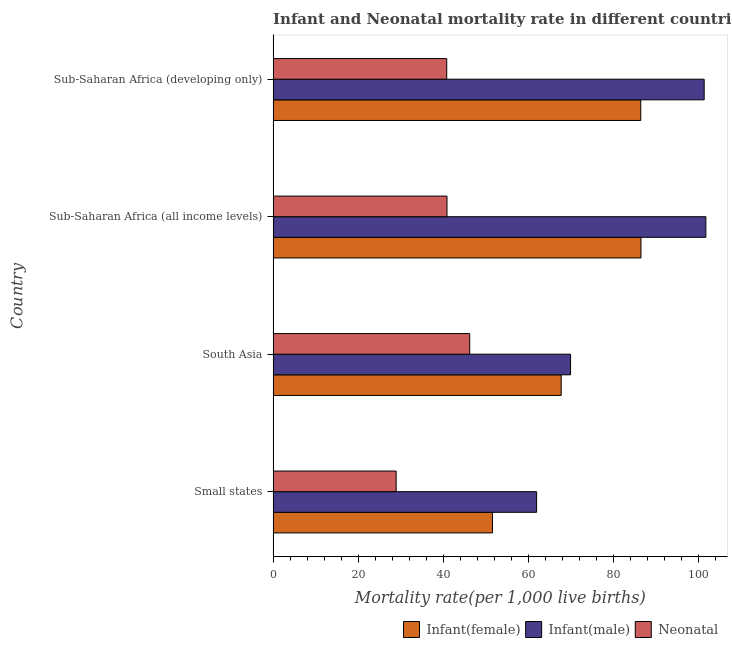How many different coloured bars are there?
Keep it short and to the point. 3. Are the number of bars per tick equal to the number of legend labels?
Provide a short and direct response. Yes. What is the infant mortality rate(male) in Sub-Saharan Africa (all income levels)?
Keep it short and to the point. 101.7. Across all countries, what is the maximum infant mortality rate(male)?
Your answer should be compact. 101.7. Across all countries, what is the minimum neonatal mortality rate?
Provide a succinct answer. 28.91. In which country was the neonatal mortality rate maximum?
Provide a short and direct response. South Asia. In which country was the neonatal mortality rate minimum?
Make the answer very short. Small states. What is the total infant mortality rate(male) in the graph?
Give a very brief answer. 334.82. What is the difference between the neonatal mortality rate in South Asia and that in Sub-Saharan Africa (developing only)?
Offer a terse response. 5.4. What is the difference between the infant mortality rate(male) in South Asia and the infant mortality rate(female) in Sub-Saharan Africa (all income levels)?
Provide a succinct answer. -16.55. What is the average neonatal mortality rate per country?
Your answer should be very brief. 39.19. What is the difference between the infant mortality rate(male) and neonatal mortality rate in South Asia?
Ensure brevity in your answer.  23.7. In how many countries, is the infant mortality rate(female) greater than 96 ?
Your answer should be compact. 0. What is the ratio of the infant mortality rate(male) in Small states to that in Sub-Saharan Africa (developing only)?
Provide a succinct answer. 0.61. Is the infant mortality rate(male) in South Asia less than that in Sub-Saharan Africa (developing only)?
Offer a very short reply. Yes. What is the difference between the highest and the second highest neonatal mortality rate?
Your response must be concise. 5.34. What is the difference between the highest and the lowest infant mortality rate(female)?
Keep it short and to the point. 34.9. In how many countries, is the neonatal mortality rate greater than the average neonatal mortality rate taken over all countries?
Provide a short and direct response. 3. Is the sum of the neonatal mortality rate in South Asia and Sub-Saharan Africa (developing only) greater than the maximum infant mortality rate(male) across all countries?
Ensure brevity in your answer.  No. What does the 3rd bar from the top in South Asia represents?
Provide a short and direct response. Infant(female). What does the 1st bar from the bottom in Sub-Saharan Africa (all income levels) represents?
Offer a terse response. Infant(female). Is it the case that in every country, the sum of the infant mortality rate(female) and infant mortality rate(male) is greater than the neonatal mortality rate?
Your response must be concise. Yes. How many countries are there in the graph?
Give a very brief answer. 4. What is the difference between two consecutive major ticks on the X-axis?
Ensure brevity in your answer.  20. Does the graph contain grids?
Provide a succinct answer. No. Where does the legend appear in the graph?
Your answer should be very brief. Bottom right. How many legend labels are there?
Your answer should be compact. 3. How are the legend labels stacked?
Ensure brevity in your answer.  Horizontal. What is the title of the graph?
Your answer should be very brief. Infant and Neonatal mortality rate in different countries in 2000. Does "Ages 60+" appear as one of the legend labels in the graph?
Provide a short and direct response. No. What is the label or title of the X-axis?
Provide a succinct answer. Mortality rate(per 1,0 live births). What is the label or title of the Y-axis?
Provide a short and direct response. Country. What is the Mortality rate(per 1,000 live births) in Infant(female) in Small states?
Ensure brevity in your answer.  51.55. What is the Mortality rate(per 1,000 live births) in Infant(male) in Small states?
Make the answer very short. 61.93. What is the Mortality rate(per 1,000 live births) of Neonatal  in Small states?
Provide a succinct answer. 28.91. What is the Mortality rate(per 1,000 live births) in Infant(female) in South Asia?
Provide a succinct answer. 67.7. What is the Mortality rate(per 1,000 live births) of Infant(male) in South Asia?
Keep it short and to the point. 69.9. What is the Mortality rate(per 1,000 live births) in Neonatal  in South Asia?
Provide a succinct answer. 46.2. What is the Mortality rate(per 1,000 live births) in Infant(female) in Sub-Saharan Africa (all income levels)?
Offer a very short reply. 86.45. What is the Mortality rate(per 1,000 live births) of Infant(male) in Sub-Saharan Africa (all income levels)?
Ensure brevity in your answer.  101.7. What is the Mortality rate(per 1,000 live births) in Neonatal  in Sub-Saharan Africa (all income levels)?
Keep it short and to the point. 40.86. What is the Mortality rate(per 1,000 live births) in Infant(female) in Sub-Saharan Africa (developing only)?
Keep it short and to the point. 86.4. What is the Mortality rate(per 1,000 live births) of Infant(male) in Sub-Saharan Africa (developing only)?
Offer a very short reply. 101.3. What is the Mortality rate(per 1,000 live births) in Neonatal  in Sub-Saharan Africa (developing only)?
Offer a terse response. 40.8. Across all countries, what is the maximum Mortality rate(per 1,000 live births) of Infant(female)?
Offer a terse response. 86.45. Across all countries, what is the maximum Mortality rate(per 1,000 live births) of Infant(male)?
Make the answer very short. 101.7. Across all countries, what is the maximum Mortality rate(per 1,000 live births) of Neonatal ?
Keep it short and to the point. 46.2. Across all countries, what is the minimum Mortality rate(per 1,000 live births) of Infant(female)?
Your response must be concise. 51.55. Across all countries, what is the minimum Mortality rate(per 1,000 live births) in Infant(male)?
Offer a very short reply. 61.93. Across all countries, what is the minimum Mortality rate(per 1,000 live births) of Neonatal ?
Your answer should be compact. 28.91. What is the total Mortality rate(per 1,000 live births) in Infant(female) in the graph?
Your answer should be compact. 292.09. What is the total Mortality rate(per 1,000 live births) in Infant(male) in the graph?
Give a very brief answer. 334.82. What is the total Mortality rate(per 1,000 live births) of Neonatal  in the graph?
Your answer should be very brief. 156.77. What is the difference between the Mortality rate(per 1,000 live births) in Infant(female) in Small states and that in South Asia?
Make the answer very short. -16.15. What is the difference between the Mortality rate(per 1,000 live births) of Infant(male) in Small states and that in South Asia?
Provide a short and direct response. -7.97. What is the difference between the Mortality rate(per 1,000 live births) in Neonatal  in Small states and that in South Asia?
Provide a succinct answer. -17.29. What is the difference between the Mortality rate(per 1,000 live births) in Infant(female) in Small states and that in Sub-Saharan Africa (all income levels)?
Give a very brief answer. -34.9. What is the difference between the Mortality rate(per 1,000 live births) in Infant(male) in Small states and that in Sub-Saharan Africa (all income levels)?
Ensure brevity in your answer.  -39.77. What is the difference between the Mortality rate(per 1,000 live births) of Neonatal  in Small states and that in Sub-Saharan Africa (all income levels)?
Your answer should be very brief. -11.95. What is the difference between the Mortality rate(per 1,000 live births) in Infant(female) in Small states and that in Sub-Saharan Africa (developing only)?
Your response must be concise. -34.85. What is the difference between the Mortality rate(per 1,000 live births) of Infant(male) in Small states and that in Sub-Saharan Africa (developing only)?
Your answer should be very brief. -39.37. What is the difference between the Mortality rate(per 1,000 live births) of Neonatal  in Small states and that in Sub-Saharan Africa (developing only)?
Provide a succinct answer. -11.89. What is the difference between the Mortality rate(per 1,000 live births) in Infant(female) in South Asia and that in Sub-Saharan Africa (all income levels)?
Your answer should be very brief. -18.75. What is the difference between the Mortality rate(per 1,000 live births) in Infant(male) in South Asia and that in Sub-Saharan Africa (all income levels)?
Your response must be concise. -31.8. What is the difference between the Mortality rate(per 1,000 live births) of Neonatal  in South Asia and that in Sub-Saharan Africa (all income levels)?
Provide a succinct answer. 5.34. What is the difference between the Mortality rate(per 1,000 live births) of Infant(female) in South Asia and that in Sub-Saharan Africa (developing only)?
Offer a very short reply. -18.7. What is the difference between the Mortality rate(per 1,000 live births) in Infant(male) in South Asia and that in Sub-Saharan Africa (developing only)?
Offer a very short reply. -31.4. What is the difference between the Mortality rate(per 1,000 live births) in Infant(female) in Sub-Saharan Africa (all income levels) and that in Sub-Saharan Africa (developing only)?
Make the answer very short. 0.05. What is the difference between the Mortality rate(per 1,000 live births) in Infant(male) in Sub-Saharan Africa (all income levels) and that in Sub-Saharan Africa (developing only)?
Offer a very short reply. 0.4. What is the difference between the Mortality rate(per 1,000 live births) in Neonatal  in Sub-Saharan Africa (all income levels) and that in Sub-Saharan Africa (developing only)?
Offer a very short reply. 0.06. What is the difference between the Mortality rate(per 1,000 live births) in Infant(female) in Small states and the Mortality rate(per 1,000 live births) in Infant(male) in South Asia?
Make the answer very short. -18.35. What is the difference between the Mortality rate(per 1,000 live births) of Infant(female) in Small states and the Mortality rate(per 1,000 live births) of Neonatal  in South Asia?
Your answer should be compact. 5.35. What is the difference between the Mortality rate(per 1,000 live births) in Infant(male) in Small states and the Mortality rate(per 1,000 live births) in Neonatal  in South Asia?
Give a very brief answer. 15.73. What is the difference between the Mortality rate(per 1,000 live births) in Infant(female) in Small states and the Mortality rate(per 1,000 live births) in Infant(male) in Sub-Saharan Africa (all income levels)?
Provide a short and direct response. -50.15. What is the difference between the Mortality rate(per 1,000 live births) of Infant(female) in Small states and the Mortality rate(per 1,000 live births) of Neonatal  in Sub-Saharan Africa (all income levels)?
Ensure brevity in your answer.  10.69. What is the difference between the Mortality rate(per 1,000 live births) in Infant(male) in Small states and the Mortality rate(per 1,000 live births) in Neonatal  in Sub-Saharan Africa (all income levels)?
Your answer should be compact. 21.07. What is the difference between the Mortality rate(per 1,000 live births) in Infant(female) in Small states and the Mortality rate(per 1,000 live births) in Infant(male) in Sub-Saharan Africa (developing only)?
Your answer should be compact. -49.75. What is the difference between the Mortality rate(per 1,000 live births) of Infant(female) in Small states and the Mortality rate(per 1,000 live births) of Neonatal  in Sub-Saharan Africa (developing only)?
Offer a very short reply. 10.75. What is the difference between the Mortality rate(per 1,000 live births) of Infant(male) in Small states and the Mortality rate(per 1,000 live births) of Neonatal  in Sub-Saharan Africa (developing only)?
Ensure brevity in your answer.  21.13. What is the difference between the Mortality rate(per 1,000 live births) in Infant(female) in South Asia and the Mortality rate(per 1,000 live births) in Infant(male) in Sub-Saharan Africa (all income levels)?
Your answer should be very brief. -34. What is the difference between the Mortality rate(per 1,000 live births) in Infant(female) in South Asia and the Mortality rate(per 1,000 live births) in Neonatal  in Sub-Saharan Africa (all income levels)?
Your answer should be very brief. 26.84. What is the difference between the Mortality rate(per 1,000 live births) in Infant(male) in South Asia and the Mortality rate(per 1,000 live births) in Neonatal  in Sub-Saharan Africa (all income levels)?
Make the answer very short. 29.04. What is the difference between the Mortality rate(per 1,000 live births) in Infant(female) in South Asia and the Mortality rate(per 1,000 live births) in Infant(male) in Sub-Saharan Africa (developing only)?
Offer a very short reply. -33.6. What is the difference between the Mortality rate(per 1,000 live births) of Infant(female) in South Asia and the Mortality rate(per 1,000 live births) of Neonatal  in Sub-Saharan Africa (developing only)?
Provide a short and direct response. 26.9. What is the difference between the Mortality rate(per 1,000 live births) of Infant(male) in South Asia and the Mortality rate(per 1,000 live births) of Neonatal  in Sub-Saharan Africa (developing only)?
Ensure brevity in your answer.  29.1. What is the difference between the Mortality rate(per 1,000 live births) in Infant(female) in Sub-Saharan Africa (all income levels) and the Mortality rate(per 1,000 live births) in Infant(male) in Sub-Saharan Africa (developing only)?
Give a very brief answer. -14.85. What is the difference between the Mortality rate(per 1,000 live births) of Infant(female) in Sub-Saharan Africa (all income levels) and the Mortality rate(per 1,000 live births) of Neonatal  in Sub-Saharan Africa (developing only)?
Offer a very short reply. 45.65. What is the difference between the Mortality rate(per 1,000 live births) of Infant(male) in Sub-Saharan Africa (all income levels) and the Mortality rate(per 1,000 live births) of Neonatal  in Sub-Saharan Africa (developing only)?
Give a very brief answer. 60.9. What is the average Mortality rate(per 1,000 live births) of Infant(female) per country?
Give a very brief answer. 73.02. What is the average Mortality rate(per 1,000 live births) in Infant(male) per country?
Ensure brevity in your answer.  83.71. What is the average Mortality rate(per 1,000 live births) of Neonatal  per country?
Give a very brief answer. 39.19. What is the difference between the Mortality rate(per 1,000 live births) of Infant(female) and Mortality rate(per 1,000 live births) of Infant(male) in Small states?
Offer a very short reply. -10.38. What is the difference between the Mortality rate(per 1,000 live births) of Infant(female) and Mortality rate(per 1,000 live births) of Neonatal  in Small states?
Keep it short and to the point. 22.63. What is the difference between the Mortality rate(per 1,000 live births) of Infant(male) and Mortality rate(per 1,000 live births) of Neonatal  in Small states?
Your response must be concise. 33.01. What is the difference between the Mortality rate(per 1,000 live births) of Infant(female) and Mortality rate(per 1,000 live births) of Infant(male) in South Asia?
Make the answer very short. -2.2. What is the difference between the Mortality rate(per 1,000 live births) in Infant(female) and Mortality rate(per 1,000 live births) in Neonatal  in South Asia?
Make the answer very short. 21.5. What is the difference between the Mortality rate(per 1,000 live births) of Infant(male) and Mortality rate(per 1,000 live births) of Neonatal  in South Asia?
Make the answer very short. 23.7. What is the difference between the Mortality rate(per 1,000 live births) in Infant(female) and Mortality rate(per 1,000 live births) in Infant(male) in Sub-Saharan Africa (all income levels)?
Your answer should be very brief. -15.25. What is the difference between the Mortality rate(per 1,000 live births) of Infant(female) and Mortality rate(per 1,000 live births) of Neonatal  in Sub-Saharan Africa (all income levels)?
Make the answer very short. 45.59. What is the difference between the Mortality rate(per 1,000 live births) of Infant(male) and Mortality rate(per 1,000 live births) of Neonatal  in Sub-Saharan Africa (all income levels)?
Make the answer very short. 60.84. What is the difference between the Mortality rate(per 1,000 live births) in Infant(female) and Mortality rate(per 1,000 live births) in Infant(male) in Sub-Saharan Africa (developing only)?
Your answer should be very brief. -14.9. What is the difference between the Mortality rate(per 1,000 live births) of Infant(female) and Mortality rate(per 1,000 live births) of Neonatal  in Sub-Saharan Africa (developing only)?
Offer a very short reply. 45.6. What is the difference between the Mortality rate(per 1,000 live births) of Infant(male) and Mortality rate(per 1,000 live births) of Neonatal  in Sub-Saharan Africa (developing only)?
Offer a terse response. 60.5. What is the ratio of the Mortality rate(per 1,000 live births) of Infant(female) in Small states to that in South Asia?
Provide a succinct answer. 0.76. What is the ratio of the Mortality rate(per 1,000 live births) of Infant(male) in Small states to that in South Asia?
Your response must be concise. 0.89. What is the ratio of the Mortality rate(per 1,000 live births) in Neonatal  in Small states to that in South Asia?
Provide a short and direct response. 0.63. What is the ratio of the Mortality rate(per 1,000 live births) of Infant(female) in Small states to that in Sub-Saharan Africa (all income levels)?
Your answer should be compact. 0.6. What is the ratio of the Mortality rate(per 1,000 live births) of Infant(male) in Small states to that in Sub-Saharan Africa (all income levels)?
Your response must be concise. 0.61. What is the ratio of the Mortality rate(per 1,000 live births) in Neonatal  in Small states to that in Sub-Saharan Africa (all income levels)?
Provide a succinct answer. 0.71. What is the ratio of the Mortality rate(per 1,000 live births) in Infant(female) in Small states to that in Sub-Saharan Africa (developing only)?
Give a very brief answer. 0.6. What is the ratio of the Mortality rate(per 1,000 live births) of Infant(male) in Small states to that in Sub-Saharan Africa (developing only)?
Your response must be concise. 0.61. What is the ratio of the Mortality rate(per 1,000 live births) in Neonatal  in Small states to that in Sub-Saharan Africa (developing only)?
Ensure brevity in your answer.  0.71. What is the ratio of the Mortality rate(per 1,000 live births) in Infant(female) in South Asia to that in Sub-Saharan Africa (all income levels)?
Your response must be concise. 0.78. What is the ratio of the Mortality rate(per 1,000 live births) of Infant(male) in South Asia to that in Sub-Saharan Africa (all income levels)?
Offer a terse response. 0.69. What is the ratio of the Mortality rate(per 1,000 live births) in Neonatal  in South Asia to that in Sub-Saharan Africa (all income levels)?
Give a very brief answer. 1.13. What is the ratio of the Mortality rate(per 1,000 live births) in Infant(female) in South Asia to that in Sub-Saharan Africa (developing only)?
Your answer should be compact. 0.78. What is the ratio of the Mortality rate(per 1,000 live births) of Infant(male) in South Asia to that in Sub-Saharan Africa (developing only)?
Your response must be concise. 0.69. What is the ratio of the Mortality rate(per 1,000 live births) of Neonatal  in South Asia to that in Sub-Saharan Africa (developing only)?
Offer a terse response. 1.13. What is the ratio of the Mortality rate(per 1,000 live births) in Neonatal  in Sub-Saharan Africa (all income levels) to that in Sub-Saharan Africa (developing only)?
Your answer should be very brief. 1. What is the difference between the highest and the second highest Mortality rate(per 1,000 live births) of Infant(female)?
Provide a succinct answer. 0.05. What is the difference between the highest and the second highest Mortality rate(per 1,000 live births) in Infant(male)?
Provide a short and direct response. 0.4. What is the difference between the highest and the second highest Mortality rate(per 1,000 live births) in Neonatal ?
Provide a short and direct response. 5.34. What is the difference between the highest and the lowest Mortality rate(per 1,000 live births) in Infant(female)?
Give a very brief answer. 34.9. What is the difference between the highest and the lowest Mortality rate(per 1,000 live births) in Infant(male)?
Your answer should be compact. 39.77. What is the difference between the highest and the lowest Mortality rate(per 1,000 live births) in Neonatal ?
Give a very brief answer. 17.29. 